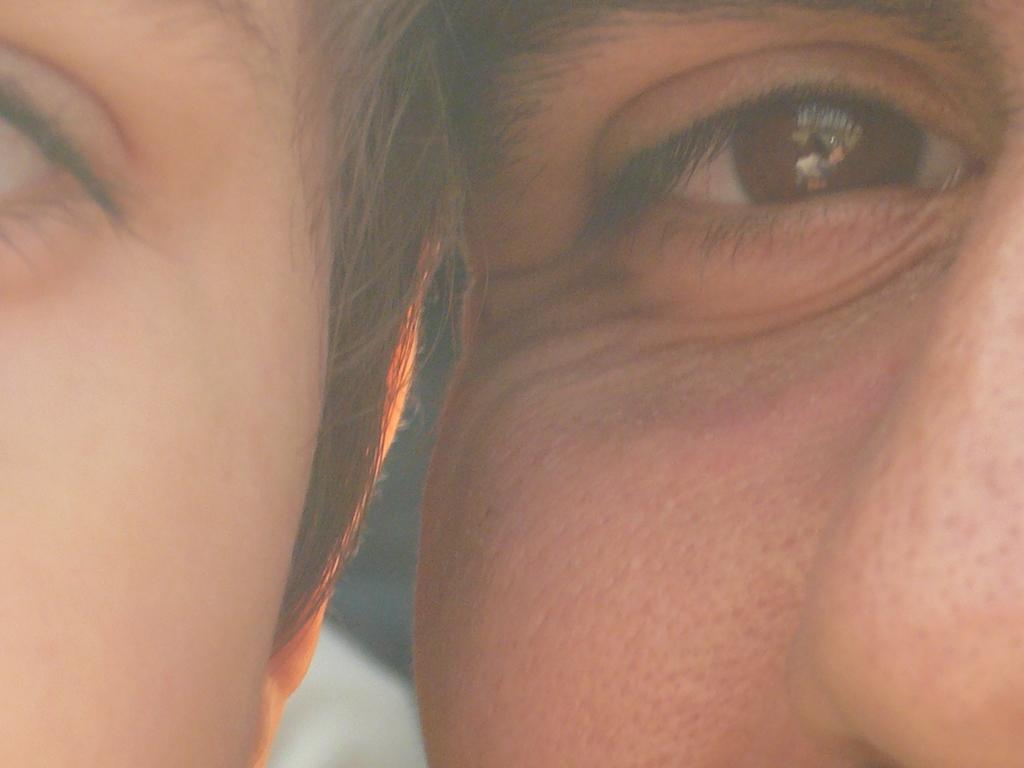How many faces can be seen in the image? There are two persons' faces in the image. Where is the face on the left side of the image located? The face on the left side of the image is on the left side of the image. Where is the face on the right side of the image located? The face on the right side of the image is on the right side of the image. What features are visible on the faces in the image? Eyes are visible in the image. How many pizzas are being delivered to the hill in the image? There is no hill or pizzas present in the image; it only features two faces with visible eyes. 